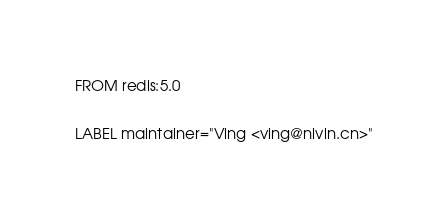<code> <loc_0><loc_0><loc_500><loc_500><_Dockerfile_>FROM redis:5.0

LABEL maintainer="Ving <ving@nivin.cn>"
</code> 